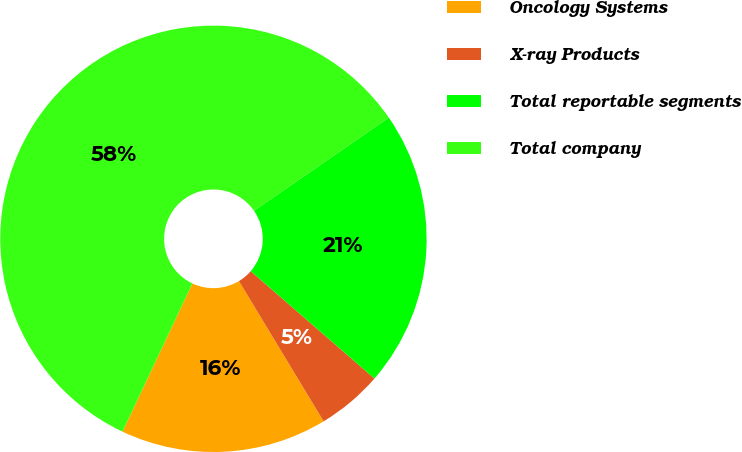<chart> <loc_0><loc_0><loc_500><loc_500><pie_chart><fcel>Oncology Systems<fcel>X-ray Products<fcel>Total reportable segments<fcel>Total company<nl><fcel>15.66%<fcel>4.98%<fcel>21.0%<fcel>58.36%<nl></chart> 